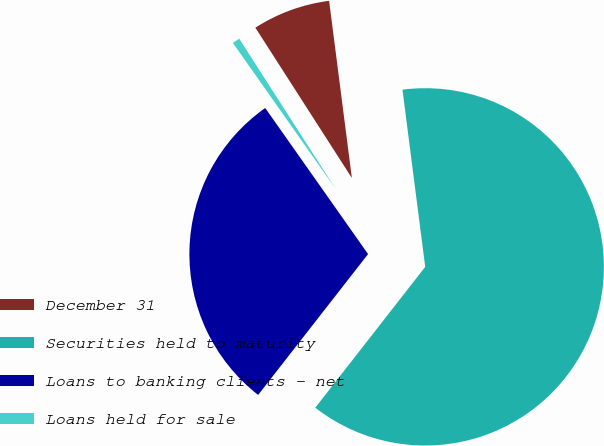<chart> <loc_0><loc_0><loc_500><loc_500><pie_chart><fcel>December 31<fcel>Securities held to maturity<fcel>Loans to banking clients - net<fcel>Loans held for sale<nl><fcel>7.05%<fcel>62.58%<fcel>29.69%<fcel>0.68%<nl></chart> 